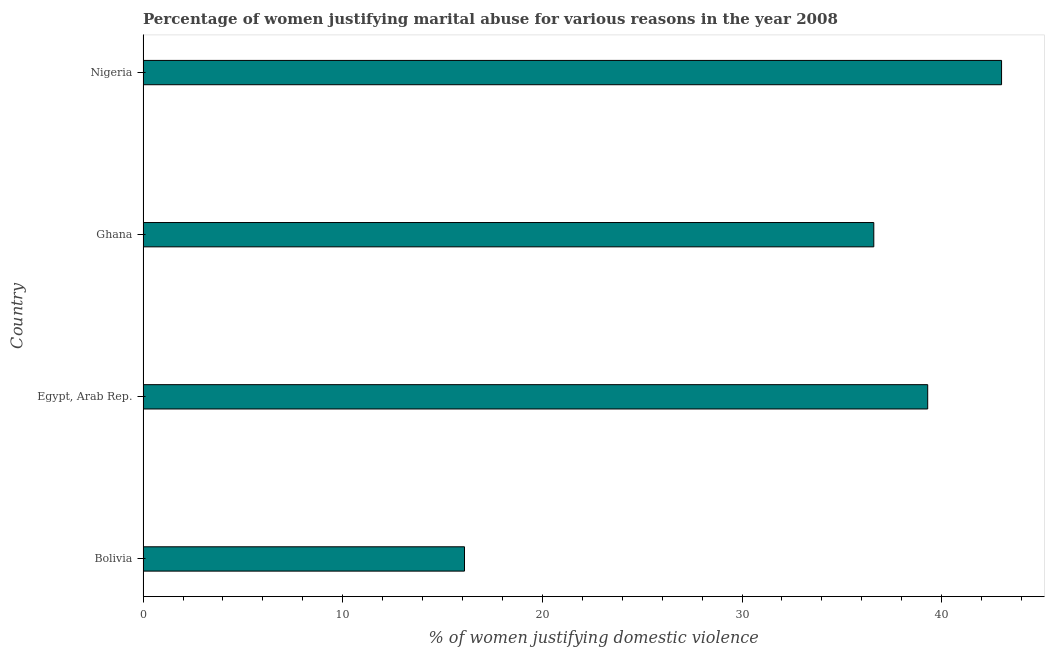Does the graph contain any zero values?
Ensure brevity in your answer.  No. Does the graph contain grids?
Give a very brief answer. No. What is the title of the graph?
Offer a terse response. Percentage of women justifying marital abuse for various reasons in the year 2008. What is the label or title of the X-axis?
Offer a very short reply. % of women justifying domestic violence. What is the label or title of the Y-axis?
Offer a very short reply. Country. What is the percentage of women justifying marital abuse in Ghana?
Your answer should be compact. 36.6. Across all countries, what is the maximum percentage of women justifying marital abuse?
Ensure brevity in your answer.  43. Across all countries, what is the minimum percentage of women justifying marital abuse?
Offer a terse response. 16.1. In which country was the percentage of women justifying marital abuse maximum?
Provide a succinct answer. Nigeria. In which country was the percentage of women justifying marital abuse minimum?
Offer a very short reply. Bolivia. What is the sum of the percentage of women justifying marital abuse?
Offer a very short reply. 135. What is the average percentage of women justifying marital abuse per country?
Your answer should be compact. 33.75. What is the median percentage of women justifying marital abuse?
Keep it short and to the point. 37.95. What is the ratio of the percentage of women justifying marital abuse in Bolivia to that in Ghana?
Give a very brief answer. 0.44. What is the difference between the highest and the second highest percentage of women justifying marital abuse?
Your response must be concise. 3.7. Is the sum of the percentage of women justifying marital abuse in Bolivia and Egypt, Arab Rep. greater than the maximum percentage of women justifying marital abuse across all countries?
Provide a short and direct response. Yes. What is the difference between the highest and the lowest percentage of women justifying marital abuse?
Give a very brief answer. 26.9. How many bars are there?
Provide a short and direct response. 4. What is the difference between two consecutive major ticks on the X-axis?
Keep it short and to the point. 10. Are the values on the major ticks of X-axis written in scientific E-notation?
Make the answer very short. No. What is the % of women justifying domestic violence in Bolivia?
Your response must be concise. 16.1. What is the % of women justifying domestic violence of Egypt, Arab Rep.?
Keep it short and to the point. 39.3. What is the % of women justifying domestic violence in Ghana?
Your answer should be compact. 36.6. What is the difference between the % of women justifying domestic violence in Bolivia and Egypt, Arab Rep.?
Your answer should be very brief. -23.2. What is the difference between the % of women justifying domestic violence in Bolivia and Ghana?
Provide a short and direct response. -20.5. What is the difference between the % of women justifying domestic violence in Bolivia and Nigeria?
Keep it short and to the point. -26.9. What is the difference between the % of women justifying domestic violence in Egypt, Arab Rep. and Nigeria?
Make the answer very short. -3.7. What is the difference between the % of women justifying domestic violence in Ghana and Nigeria?
Provide a succinct answer. -6.4. What is the ratio of the % of women justifying domestic violence in Bolivia to that in Egypt, Arab Rep.?
Make the answer very short. 0.41. What is the ratio of the % of women justifying domestic violence in Bolivia to that in Ghana?
Provide a short and direct response. 0.44. What is the ratio of the % of women justifying domestic violence in Bolivia to that in Nigeria?
Provide a succinct answer. 0.37. What is the ratio of the % of women justifying domestic violence in Egypt, Arab Rep. to that in Ghana?
Keep it short and to the point. 1.07. What is the ratio of the % of women justifying domestic violence in Egypt, Arab Rep. to that in Nigeria?
Provide a short and direct response. 0.91. What is the ratio of the % of women justifying domestic violence in Ghana to that in Nigeria?
Give a very brief answer. 0.85. 